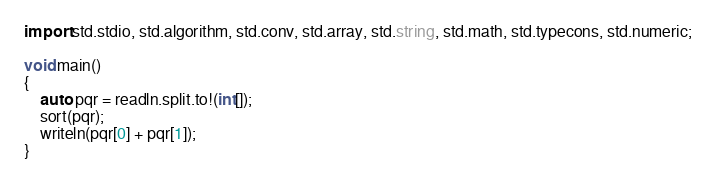Convert code to text. <code><loc_0><loc_0><loc_500><loc_500><_D_>import std.stdio, std.algorithm, std.conv, std.array, std.string, std.math, std.typecons, std.numeric;

void main()
{
    auto pqr = readln.split.to!(int[]);
    sort(pqr);
    writeln(pqr[0] + pqr[1]);
}</code> 